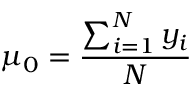<formula> <loc_0><loc_0><loc_500><loc_500>\mu _ { 0 } = \frac { \sum _ { i = 1 } ^ { N } y _ { i } } { N }</formula> 